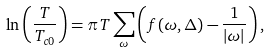<formula> <loc_0><loc_0><loc_500><loc_500>\ln \left ( \frac { T } { T _ { c 0 } } \right ) = \pi T \sum _ { \omega } \left ( f ( \omega , \Delta ) - \frac { 1 } { | \omega | } \right ) ,</formula> 